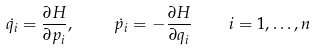Convert formula to latex. <formula><loc_0><loc_0><loc_500><loc_500>\dot { q _ { i } } = \frac { \partial H } { \partial p _ { i } } , \quad \, \dot { p _ { i } } = - \frac { \partial H } { \partial q _ { i } } \quad i = 1 , \dots , n</formula> 